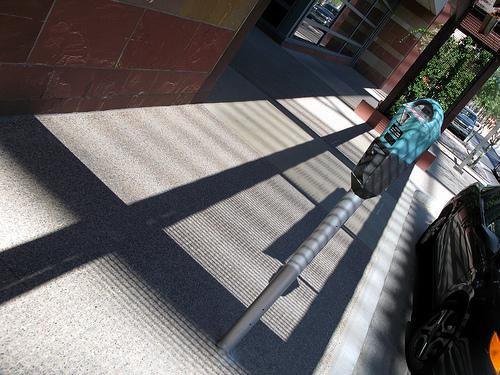Explain what the parking meter looks like, including its colors and the stickers on it. The parking meter is blue and black. The blue portion has two black stickers on it, and the black portion is at the bottom half of the meter. Analyze the sentiment expressed in the image, if any. The image expresses a neutral sentiment as it shows regular everyday life with parked cars, buildings, and sidewalks. Please provide the colors of the vehicles parked in the image. The black car is shiny, the blue truck is parked, and there is a blue car in the background. How many vehicles are visible in the image and what are their types? There are three vehicles in the image: a black car, a blue truck, and a blue car. What are the main objects in the image related to transportation? A black car parking next to the sidewalk, a blue truck parked along the road and a blue car in the background. What can you say about the building in the image and the materials used for the wall and sidewalks? The building has a large square tile covered wall made of stones that are red, yellow, and brown in color. The sidewalk is made of concrete and is gray in color. What objects are related to the parking meter and its support structure? The objects related are the silver metal pole supporting the blue and black parking meter, the gray pole the meter is mounted on, and the sidewalk where it is located. Give a brief description of the entrances and windows of the building. The entrance of the building is surrounded by a glass partition, while the windows are found on the brick part of the building. Describe the plants seen in the image. There is a tree beyond the covered area and green house plants in front of the building. Count the number of windows on the brick building and describe their appearance. There are windows on the brick building, which are square and symmetrically aligned. Are the plants in front of the building real or artificial? The plants are real and appear to be houseplants. What emotions or feelings does this image evoke? The image has a neutral, everyday scenario. No specific emotions or feelings are evoked. Which objects are next to the sidewalk in the image? A black car and a parking meter are next to the sidewalk. What material is the wall made of? The wall is made of stone. Identify the color of the parking meter. The parking meter is blue and black. What type of surface is the sidewalk made of? The sidewalk is made of concrete. Describe the scene in the image. The image features a street scene with a parked black car next to a blue and black parking meter, a building with windows, a blue truck, and a sidewalk. How many windows are there in the front of the building? There are several windows in the front of the building. Determine the quality of the image. The image is clear and detailed with well-defined objects. List the colors of the bricks in the wall. The bricks in the wall are red and yellow. Count the number of vehicles in the image. There are at least three vehicles in the image: a black car, a blue truck, and a partly visible car. Detect any text present in the image. There is no visible text in the image. Are there any anomalies or unusual objects in the image? No, there are no anomalies or unusual objects in the image. Is the blue truck parked or moving? The blue truck is parked. Where can you find a tree in the image? A tree can be found at X:402 Y:43 Width:81 Height:81. What objects are interacting with the parking meter? A black car is parked next to the parking meter, and a silver metal pole supports it. Locate a car that is only partly visible in the image. A car partly captured is located at X:405 Y:168 Width:94 Height:94. Label the areas corresponding to the sidewalk and the building in the image. The sidewalk is located at X:1 Y:102 Width:381 Height:381, and the building is located near X:281 Y:1 Width:107 Height:107. Determine the primary color of the blue truck. The primary color of the blue truck is blue. Is there a light on the front of any car in the image? Yes, there is a light on the front of a car located at X:486 Y:329 Width:12 Height:12. 